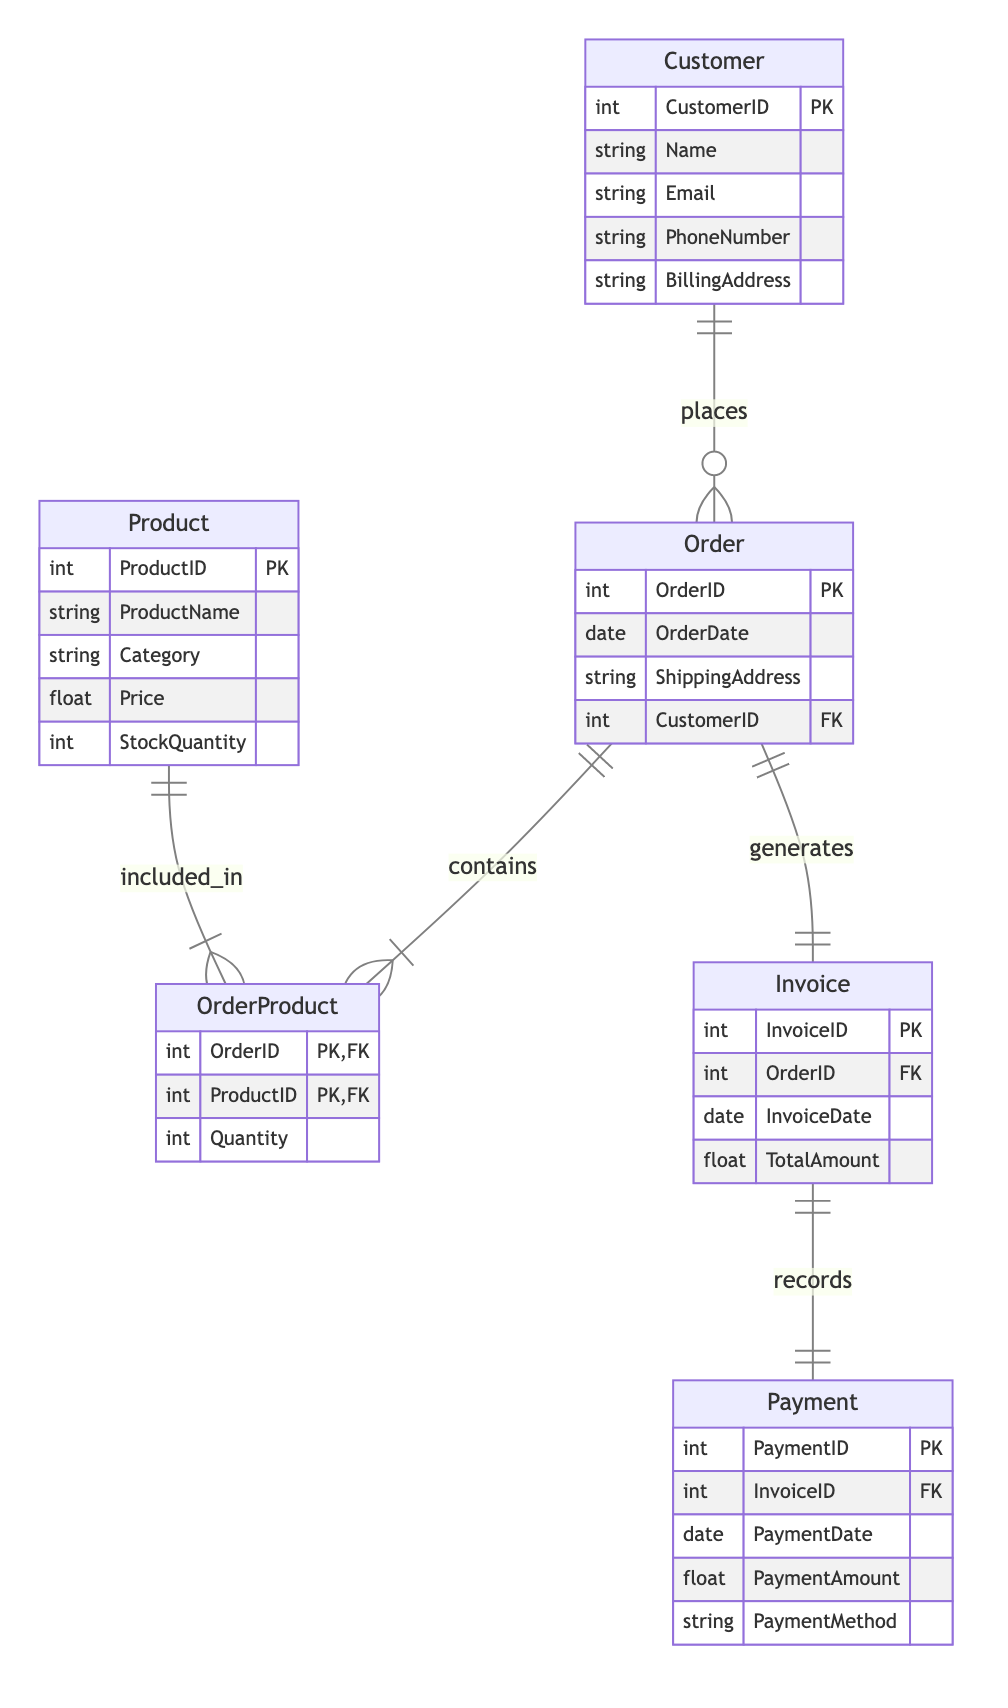What is the primary key of the Customer entity? The primary key for the Customer entity is indicated in the diagram with the label "PK". According to the information provided, the primary key for Customer is "CustomerID".
Answer: CustomerID How many attributes does the Order entity have? To determine the number of attributes in the Order entity, we count the listed attributes: "OrderID", "OrderDate", "ShippingAddress", and "CustomerID", which totals to four attributes.
Answer: 4 Which entity records payments? The diagram specifies that payments are associated with the Invoice entity through a one-to-one relationship. Hence, the entity that records payments is "Invoice".
Answer: Invoice What is the relationship type between Order and Product? The relationship between Order and Product is described as a many-to-many relationship, which is denoted in the diagram with "Order_Contains_Products" specified as many-to-many. Thus, the answer is this relationship type.
Answer: many-to-many How many entities are represented in the diagram? To find how many entities are represented, we simply count the number of entities listed in the data: Customer, Order, Product, OrderProduct, Invoice, and Payment, making a total of six entities.
Answer: 6 Which entity is linked to the Invoice entity by a foreign key? The diagram shows a one-to-one relationship where the Invoice entity has a foreign key referencing the Order entity depicted as "OrderID". Therefore, the entity linked to Invoice through a foreign key is "Order".
Answer: Order What attribute is used to connect Order and Customer? The relationship between Order and Customer is established through the "CustomerID" attribute, which is a foreign key in the Order entity referencing the primary key of the Customer entity.
Answer: CustomerID How many relationships are there in total between entities? Counting the relationships listed—Customer_Orders, Order_Contains_Products, Order_Has_Invoice, and Invoice_Has_Payment—we find that there are a total of four relationships present in the diagram.
Answer: 4 What does the OrderProduct entity represent in this diagram? The OrderProduct entity acts as a linking table in a many-to-many relationship between the Order and Product entities. It captures the association of multiple products within a single order, hence it represents the inclusion of products in orders.
Answer: linking table 